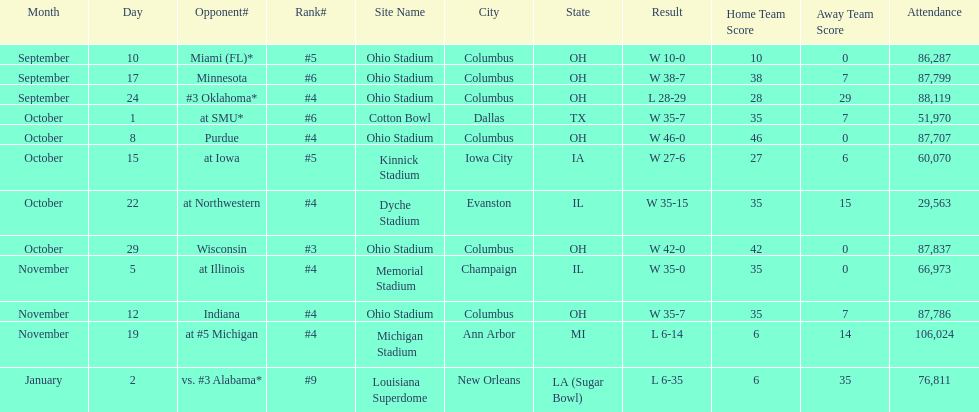What was the last game to be attended by fewer than 30,000 people? October 22. 